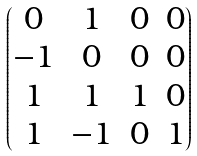Convert formula to latex. <formula><loc_0><loc_0><loc_500><loc_500>\begin{pmatrix} 0 & 1 & 0 & 0 \\ - 1 & 0 & 0 & 0 \\ 1 & 1 & 1 & 0 \\ 1 & - 1 & 0 & 1 \end{pmatrix}</formula> 